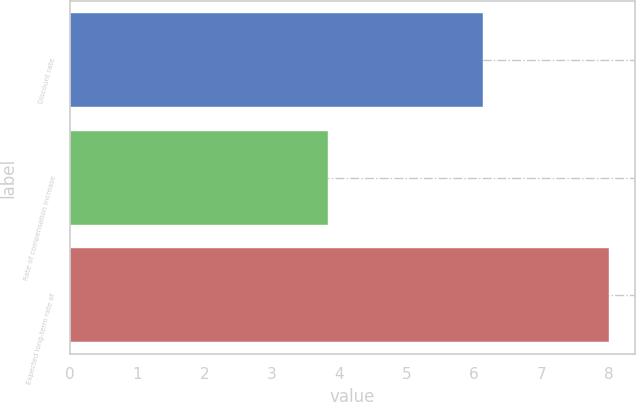<chart> <loc_0><loc_0><loc_500><loc_500><bar_chart><fcel>Discount rate<fcel>Rate of compensation increase<fcel>Expected long-term rate of<nl><fcel>6.14<fcel>3.84<fcel>8<nl></chart> 